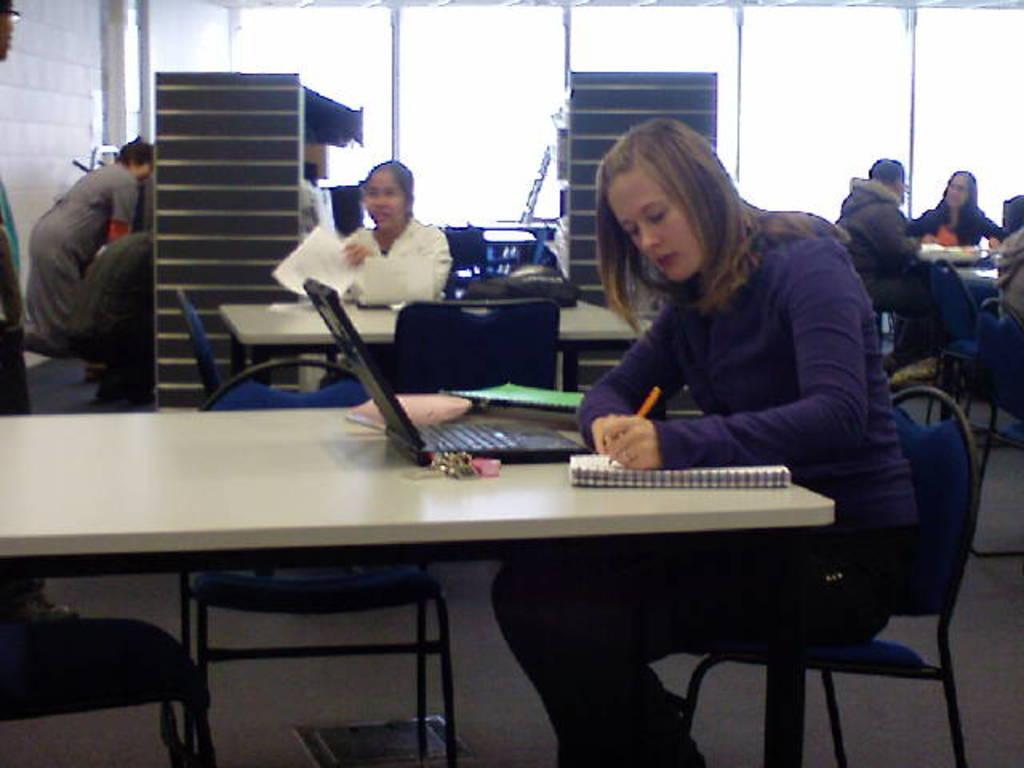What are the people in the image doing? The people in the image are sitting on chairs. What is present in the image besides the people? There is a table in the image. What items can be seen on the table? There is a book, a laptop, and a paper on the table. Where is the nest located in the image? There is no nest present in the image. What type of boot is being used by the people in the image? There is no boot visible in the image; the people are sitting on chairs. 